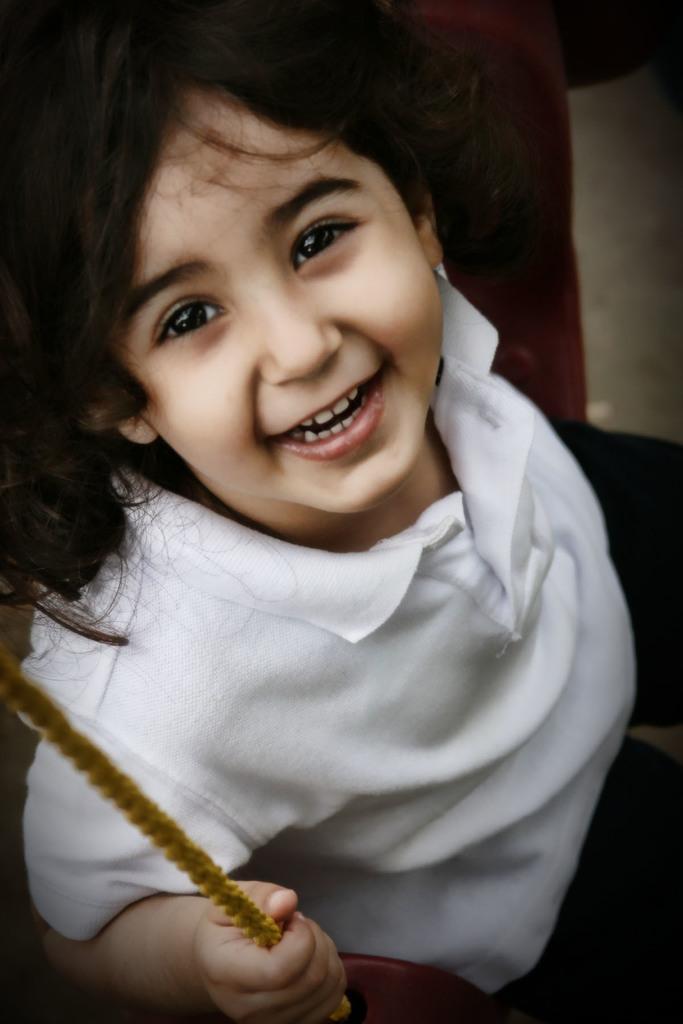In one or two sentences, can you explain what this image depicts? In this image we can see a girl. She is wearing a white color T-shirt with black pants and holding a rope in her hand. It seems like she is sitting on the swing. 